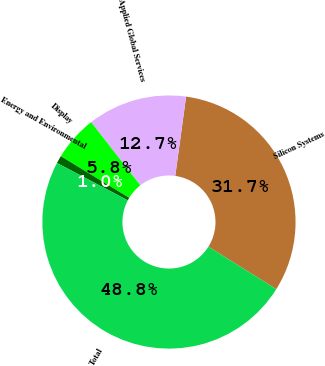Convert chart to OTSL. <chart><loc_0><loc_0><loc_500><loc_500><pie_chart><fcel>Silicon Systems<fcel>Applied Global Services<fcel>Display<fcel>Energy and Environmental<fcel>Total<nl><fcel>31.74%<fcel>12.7%<fcel>5.76%<fcel>0.98%<fcel>48.83%<nl></chart> 